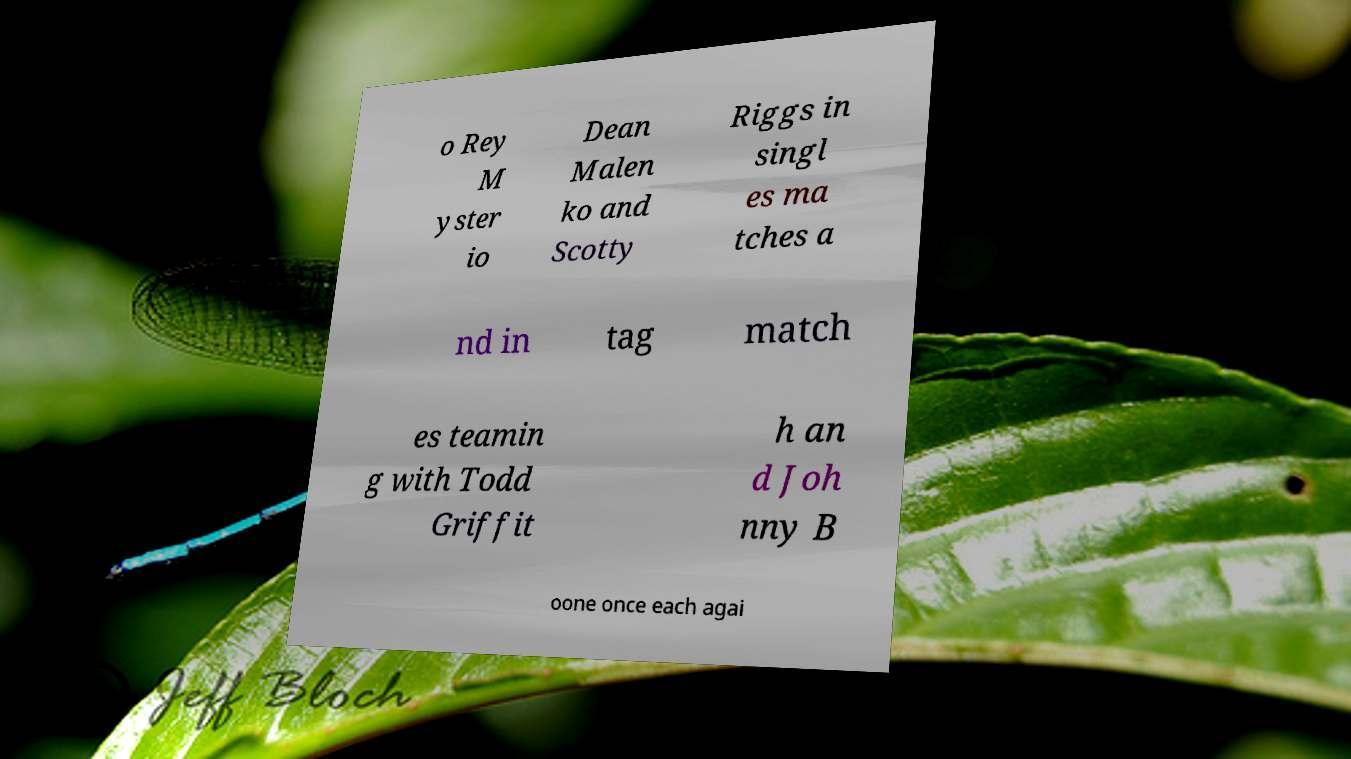For documentation purposes, I need the text within this image transcribed. Could you provide that? o Rey M yster io Dean Malen ko and Scotty Riggs in singl es ma tches a nd in tag match es teamin g with Todd Griffit h an d Joh nny B oone once each agai 